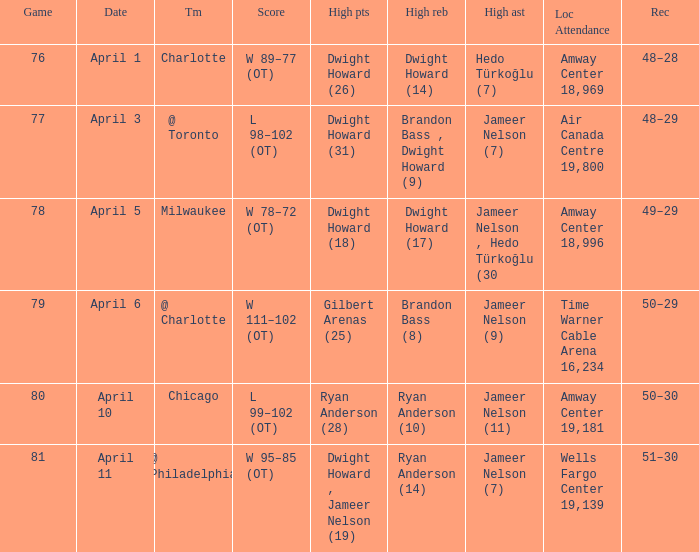Where was the game and what was the attendance on April 3?  Air Canada Centre 19,800. 